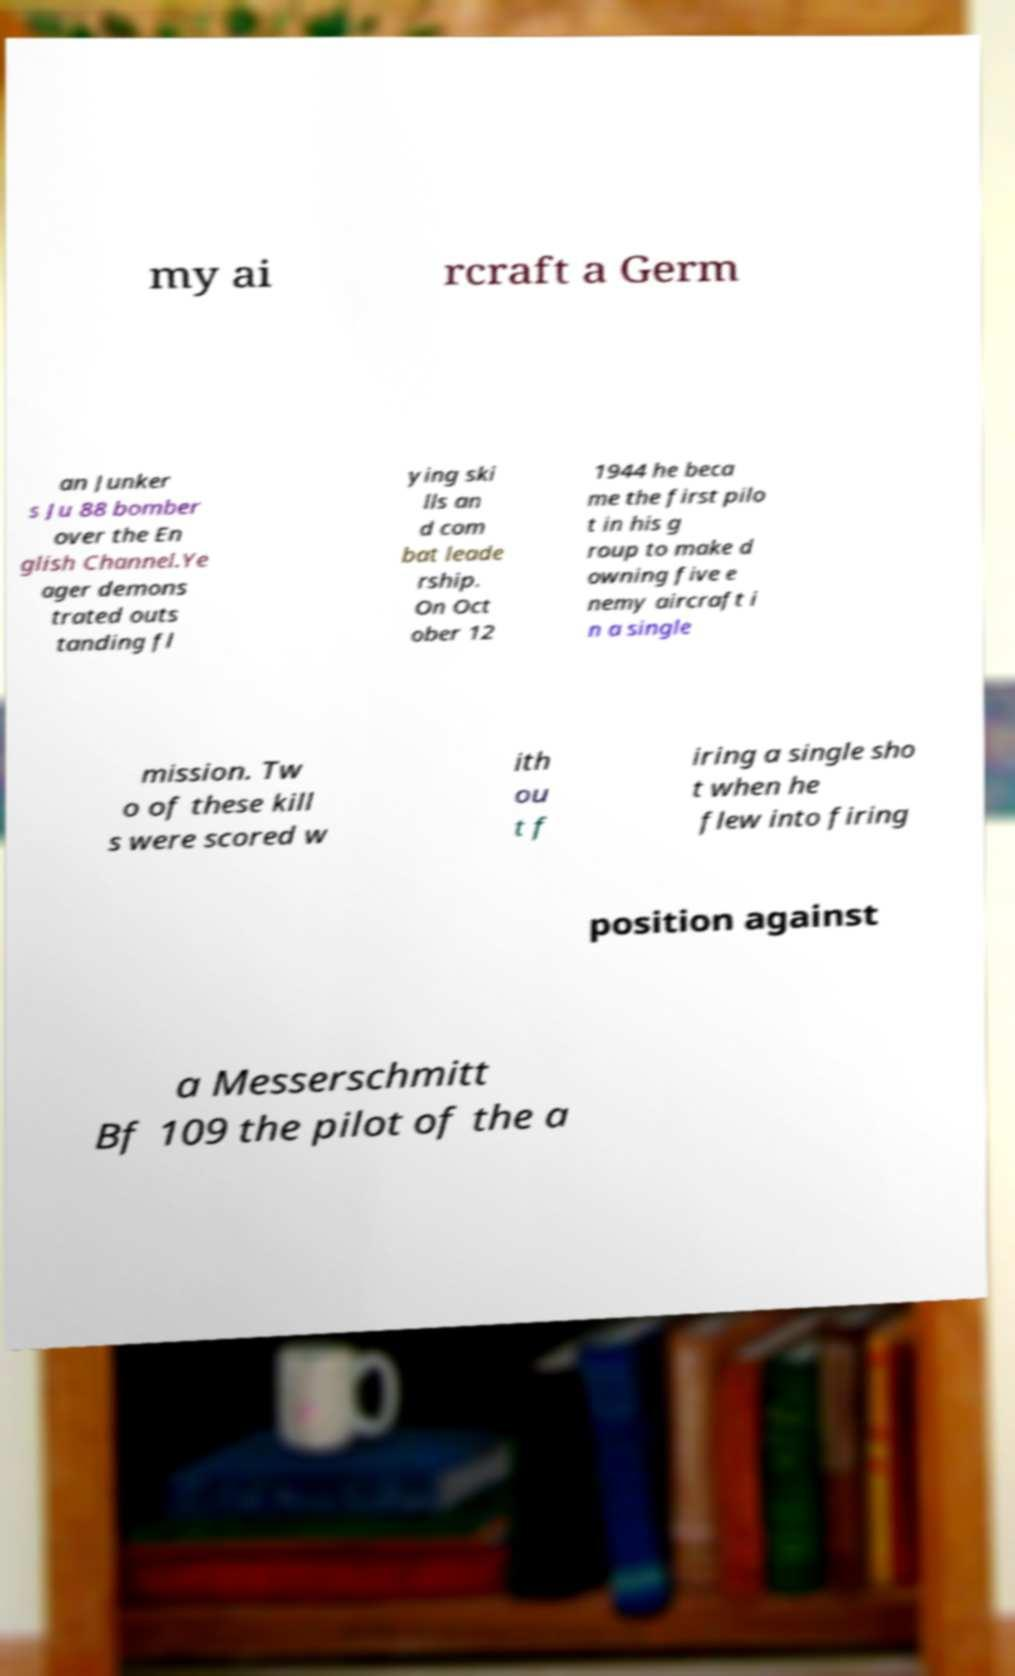For documentation purposes, I need the text within this image transcribed. Could you provide that? my ai rcraft a Germ an Junker s Ju 88 bomber over the En glish Channel.Ye ager demons trated outs tanding fl ying ski lls an d com bat leade rship. On Oct ober 12 1944 he beca me the first pilo t in his g roup to make d owning five e nemy aircraft i n a single mission. Tw o of these kill s were scored w ith ou t f iring a single sho t when he flew into firing position against a Messerschmitt Bf 109 the pilot of the a 